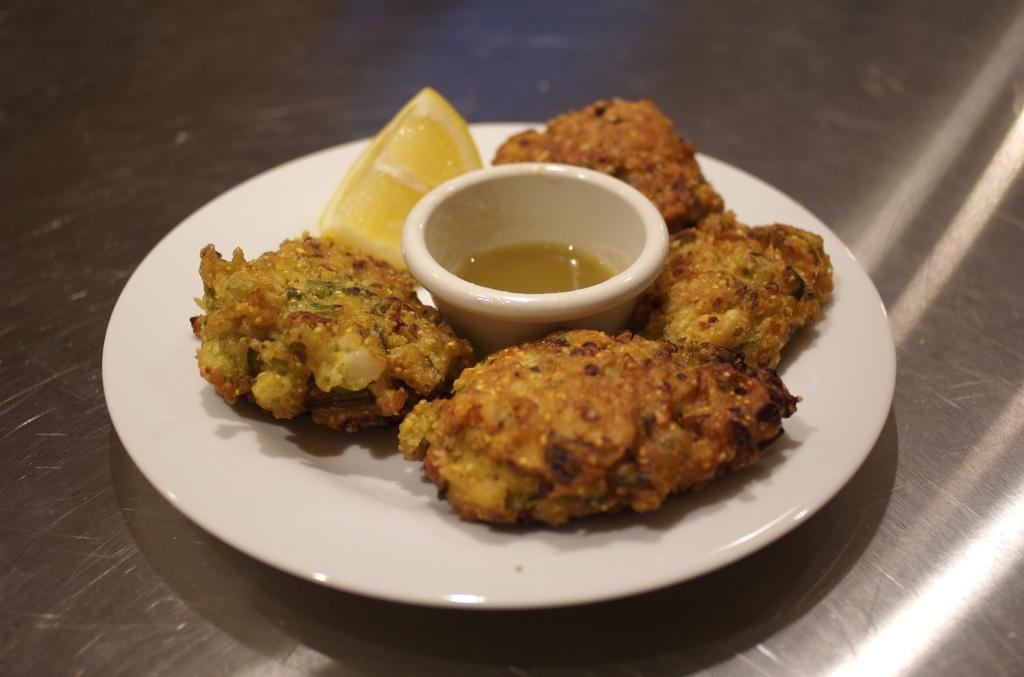What type of food items can be seen in the image? There are food items in the image, including a bowl of soup. Can you describe the bowl of soup in the image? Yes, there is a bowl of soup in the image. What other food item is present in the image? There is a lemon in the image. What color is the plate that the food items are on? The plate is white in color. What type of surface is the plate resting on? The plate is on a wooden surface. How much profit does the fireman make from the lemon in the image? There is no fireman or profit mentioned in the image; it only features food items, a plate, and a wooden surface. 